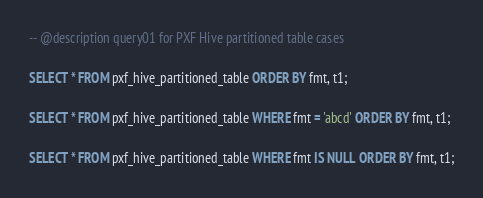Convert code to text. <code><loc_0><loc_0><loc_500><loc_500><_SQL_>-- @description query01 for PXF Hive partitioned table cases

SELECT * FROM pxf_hive_partitioned_table ORDER BY fmt, t1;

SELECT * FROM pxf_hive_partitioned_table WHERE fmt = 'abcd' ORDER BY fmt, t1;

SELECT * FROM pxf_hive_partitioned_table WHERE fmt IS NULL ORDER BY fmt, t1;</code> 